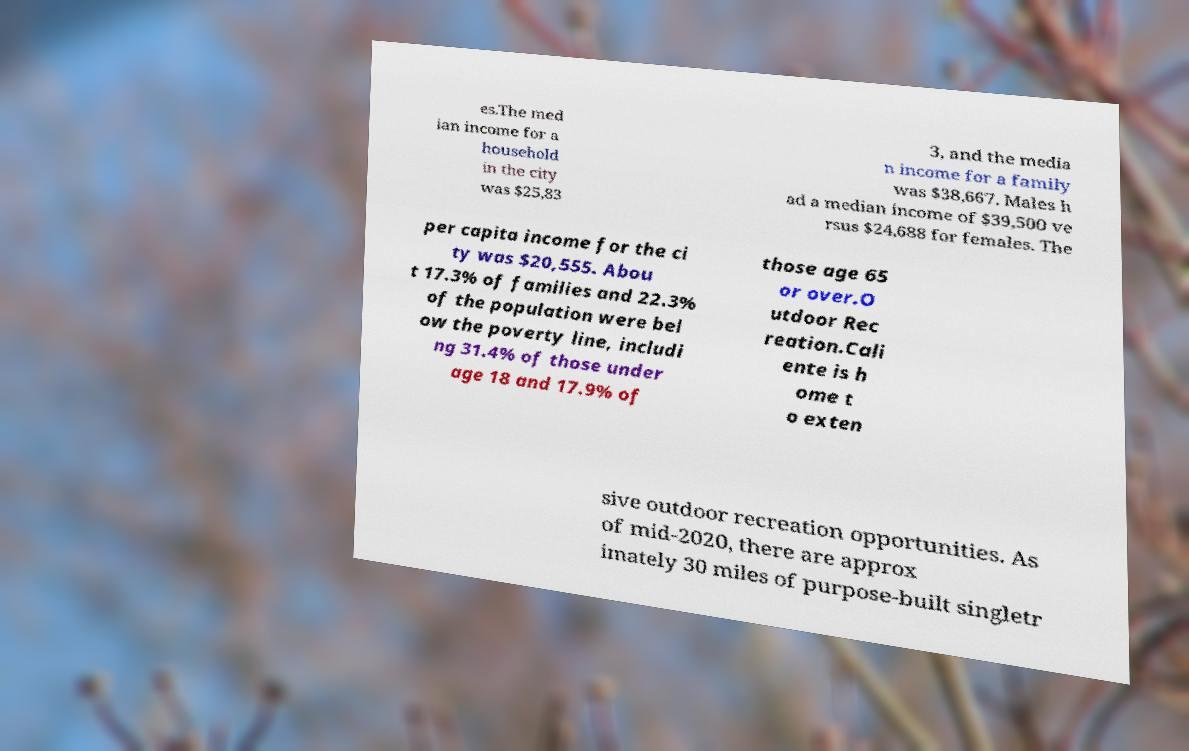Can you read and provide the text displayed in the image?This photo seems to have some interesting text. Can you extract and type it out for me? es.The med ian income for a household in the city was $25,83 3, and the media n income for a family was $38,667. Males h ad a median income of $39,500 ve rsus $24,688 for females. The per capita income for the ci ty was $20,555. Abou t 17.3% of families and 22.3% of the population were bel ow the poverty line, includi ng 31.4% of those under age 18 and 17.9% of those age 65 or over.O utdoor Rec reation.Cali ente is h ome t o exten sive outdoor recreation opportunities. As of mid-2020, there are approx imately 30 miles of purpose-built singletr 